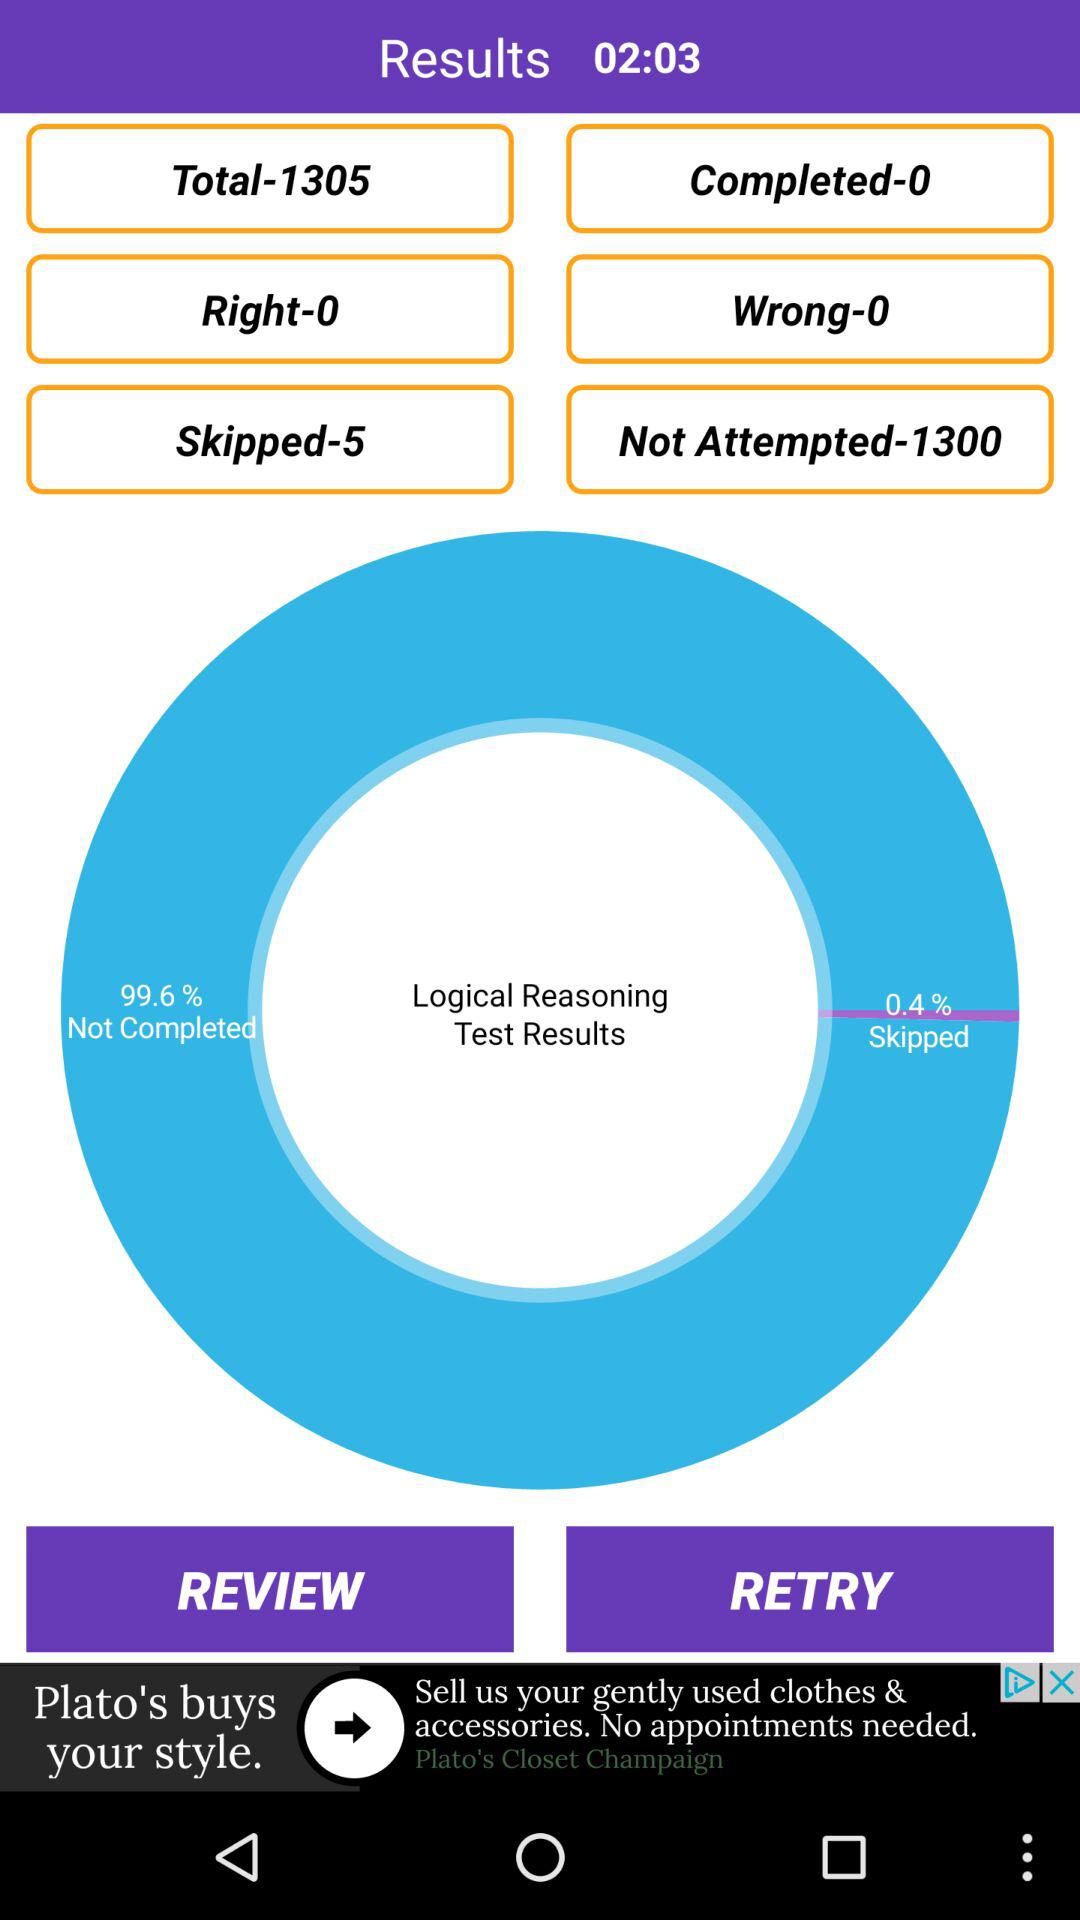How many questions are completed? There are 0 completed questions. 